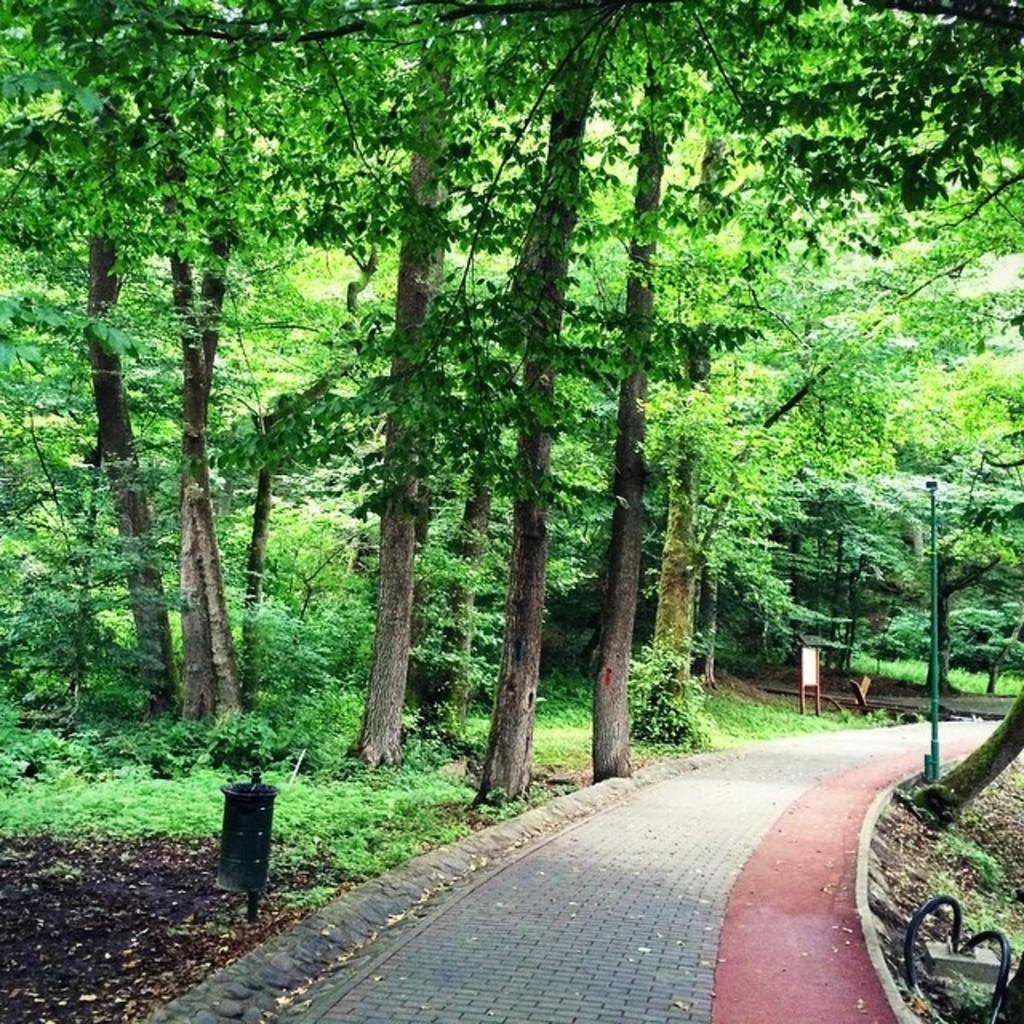What can be seen on the ground in the image? There is a pathway, a sign board, and a light pole placed on the ground in the image. What is located near the pathway in the image? There is a sign board and a light pole near the pathway in the image. What is visible in the background of the image? There is a group of trees and a trash bin in the background of the image. What type of arch can be seen in the image? There is no arch present in the image. 